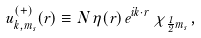Convert formula to latex. <formula><loc_0><loc_0><loc_500><loc_500>u _ { \vec { k } , m _ { s } } ^ { ( + ) } ( \vec { r } ) \equiv N \, \eta ( \vec { r } ) \, e ^ { i \vec { k } \cdot \vec { r } } \, \chi _ { \frac { 1 } { 2 } m _ { s } } \, ,</formula> 